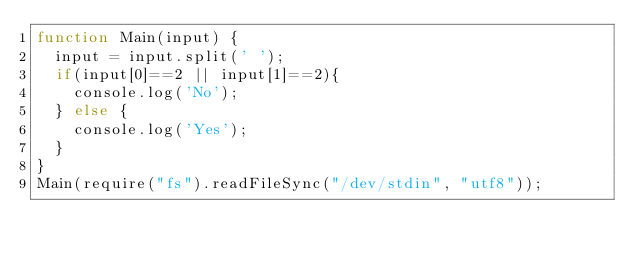<code> <loc_0><loc_0><loc_500><loc_500><_JavaScript_>function Main(input) {
  input = input.split(' ');
  if(input[0]==2 || input[1]==2){
    console.log('No');
  } else {
    console.log('Yes');
  }
}
Main(require("fs").readFileSync("/dev/stdin", "utf8"));
</code> 